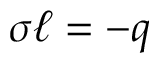<formula> <loc_0><loc_0><loc_500><loc_500>\sigma \ell = - q</formula> 